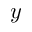<formula> <loc_0><loc_0><loc_500><loc_500>y</formula> 